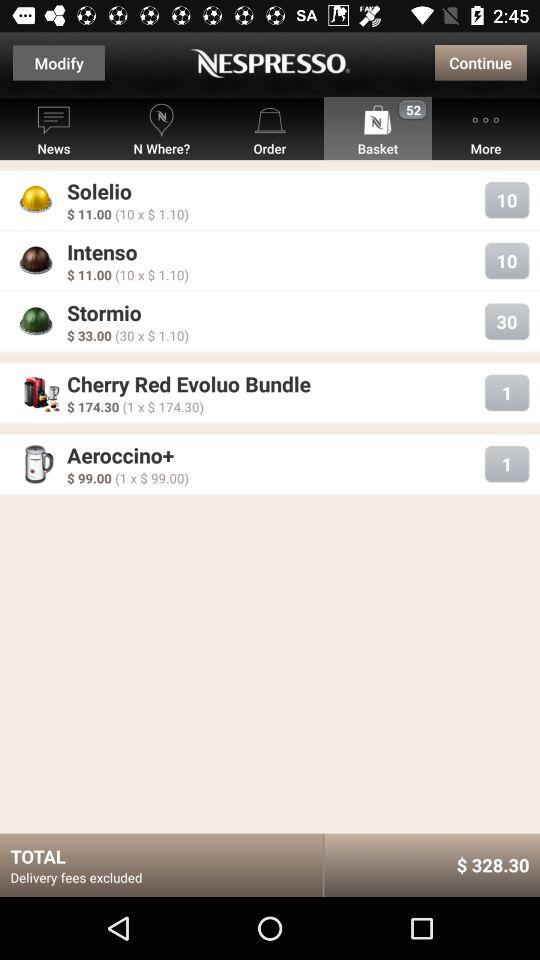How many items are in the shopping basket?
Answer the question using a single word or phrase. 5 